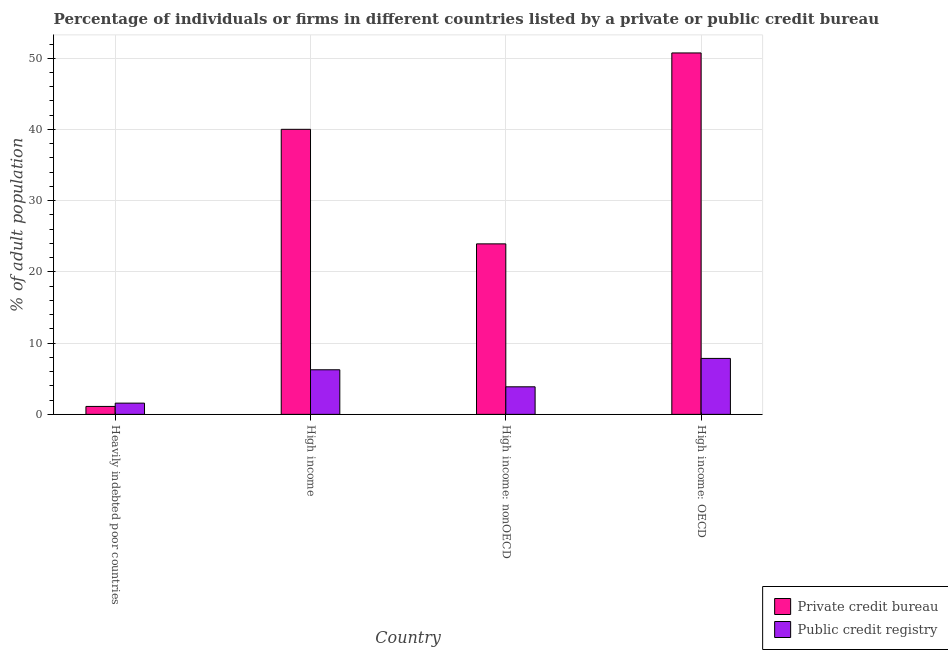How many groups of bars are there?
Keep it short and to the point. 4. Are the number of bars per tick equal to the number of legend labels?
Provide a succinct answer. Yes. Are the number of bars on each tick of the X-axis equal?
Offer a terse response. Yes. What is the label of the 1st group of bars from the left?
Offer a terse response. Heavily indebted poor countries. What is the percentage of firms listed by private credit bureau in High income: nonOECD?
Your answer should be very brief. 23.94. Across all countries, what is the maximum percentage of firms listed by private credit bureau?
Your answer should be compact. 50.75. Across all countries, what is the minimum percentage of firms listed by public credit bureau?
Provide a short and direct response. 1.58. In which country was the percentage of firms listed by public credit bureau maximum?
Ensure brevity in your answer.  High income: OECD. In which country was the percentage of firms listed by public credit bureau minimum?
Your response must be concise. Heavily indebted poor countries. What is the total percentage of firms listed by public credit bureau in the graph?
Provide a succinct answer. 19.57. What is the difference between the percentage of firms listed by public credit bureau in Heavily indebted poor countries and that in High income?
Offer a very short reply. -4.68. What is the difference between the percentage of firms listed by public credit bureau in High income: OECD and the percentage of firms listed by private credit bureau in Heavily indebted poor countries?
Give a very brief answer. 6.74. What is the average percentage of firms listed by public credit bureau per country?
Your response must be concise. 4.89. What is the difference between the percentage of firms listed by private credit bureau and percentage of firms listed by public credit bureau in Heavily indebted poor countries?
Provide a succinct answer. -0.46. What is the ratio of the percentage of firms listed by private credit bureau in High income to that in High income: OECD?
Keep it short and to the point. 0.79. What is the difference between the highest and the second highest percentage of firms listed by public credit bureau?
Offer a very short reply. 1.59. What is the difference between the highest and the lowest percentage of firms listed by private credit bureau?
Offer a terse response. 49.63. In how many countries, is the percentage of firms listed by private credit bureau greater than the average percentage of firms listed by private credit bureau taken over all countries?
Provide a succinct answer. 2. Is the sum of the percentage of firms listed by private credit bureau in High income: OECD and High income: nonOECD greater than the maximum percentage of firms listed by public credit bureau across all countries?
Offer a terse response. Yes. What does the 2nd bar from the left in High income represents?
Your answer should be very brief. Public credit registry. What does the 1st bar from the right in Heavily indebted poor countries represents?
Offer a very short reply. Public credit registry. How many bars are there?
Offer a terse response. 8. Are all the bars in the graph horizontal?
Ensure brevity in your answer.  No. Are the values on the major ticks of Y-axis written in scientific E-notation?
Keep it short and to the point. No. Does the graph contain any zero values?
Give a very brief answer. No. What is the title of the graph?
Give a very brief answer. Percentage of individuals or firms in different countries listed by a private or public credit bureau. Does "International Visitors" appear as one of the legend labels in the graph?
Provide a short and direct response. No. What is the label or title of the X-axis?
Keep it short and to the point. Country. What is the label or title of the Y-axis?
Provide a succinct answer. % of adult population. What is the % of adult population in Private credit bureau in Heavily indebted poor countries?
Your answer should be very brief. 1.12. What is the % of adult population in Public credit registry in Heavily indebted poor countries?
Offer a terse response. 1.58. What is the % of adult population of Private credit bureau in High income?
Ensure brevity in your answer.  40.02. What is the % of adult population of Public credit registry in High income?
Your answer should be very brief. 6.26. What is the % of adult population of Private credit bureau in High income: nonOECD?
Make the answer very short. 23.94. What is the % of adult population in Public credit registry in High income: nonOECD?
Provide a short and direct response. 3.87. What is the % of adult population of Private credit bureau in High income: OECD?
Your answer should be very brief. 50.75. What is the % of adult population in Public credit registry in High income: OECD?
Offer a very short reply. 7.86. Across all countries, what is the maximum % of adult population of Private credit bureau?
Your response must be concise. 50.75. Across all countries, what is the maximum % of adult population in Public credit registry?
Provide a succinct answer. 7.86. Across all countries, what is the minimum % of adult population of Private credit bureau?
Offer a very short reply. 1.12. Across all countries, what is the minimum % of adult population in Public credit registry?
Your answer should be very brief. 1.58. What is the total % of adult population of Private credit bureau in the graph?
Make the answer very short. 115.83. What is the total % of adult population in Public credit registry in the graph?
Offer a terse response. 19.57. What is the difference between the % of adult population of Private credit bureau in Heavily indebted poor countries and that in High income?
Your response must be concise. -38.91. What is the difference between the % of adult population in Public credit registry in Heavily indebted poor countries and that in High income?
Give a very brief answer. -4.68. What is the difference between the % of adult population in Private credit bureau in Heavily indebted poor countries and that in High income: nonOECD?
Provide a short and direct response. -22.82. What is the difference between the % of adult population of Public credit registry in Heavily indebted poor countries and that in High income: nonOECD?
Ensure brevity in your answer.  -2.29. What is the difference between the % of adult population in Private credit bureau in Heavily indebted poor countries and that in High income: OECD?
Your answer should be very brief. -49.63. What is the difference between the % of adult population of Public credit registry in Heavily indebted poor countries and that in High income: OECD?
Ensure brevity in your answer.  -6.28. What is the difference between the % of adult population of Private credit bureau in High income and that in High income: nonOECD?
Ensure brevity in your answer.  16.08. What is the difference between the % of adult population of Public credit registry in High income and that in High income: nonOECD?
Offer a very short reply. 2.39. What is the difference between the % of adult population in Private credit bureau in High income and that in High income: OECD?
Ensure brevity in your answer.  -10.72. What is the difference between the % of adult population in Public credit registry in High income and that in High income: OECD?
Provide a succinct answer. -1.59. What is the difference between the % of adult population of Private credit bureau in High income: nonOECD and that in High income: OECD?
Your response must be concise. -26.81. What is the difference between the % of adult population in Public credit registry in High income: nonOECD and that in High income: OECD?
Your answer should be very brief. -3.99. What is the difference between the % of adult population of Private credit bureau in Heavily indebted poor countries and the % of adult population of Public credit registry in High income?
Keep it short and to the point. -5.15. What is the difference between the % of adult population of Private credit bureau in Heavily indebted poor countries and the % of adult population of Public credit registry in High income: nonOECD?
Your answer should be compact. -2.75. What is the difference between the % of adult population of Private credit bureau in Heavily indebted poor countries and the % of adult population of Public credit registry in High income: OECD?
Your answer should be compact. -6.74. What is the difference between the % of adult population in Private credit bureau in High income and the % of adult population in Public credit registry in High income: nonOECD?
Give a very brief answer. 36.15. What is the difference between the % of adult population in Private credit bureau in High income and the % of adult population in Public credit registry in High income: OECD?
Provide a succinct answer. 32.17. What is the difference between the % of adult population in Private credit bureau in High income: nonOECD and the % of adult population in Public credit registry in High income: OECD?
Provide a short and direct response. 16.08. What is the average % of adult population in Private credit bureau per country?
Your answer should be compact. 28.96. What is the average % of adult population of Public credit registry per country?
Make the answer very short. 4.89. What is the difference between the % of adult population in Private credit bureau and % of adult population in Public credit registry in Heavily indebted poor countries?
Make the answer very short. -0.46. What is the difference between the % of adult population of Private credit bureau and % of adult population of Public credit registry in High income?
Offer a very short reply. 33.76. What is the difference between the % of adult population in Private credit bureau and % of adult population in Public credit registry in High income: nonOECD?
Offer a terse response. 20.07. What is the difference between the % of adult population of Private credit bureau and % of adult population of Public credit registry in High income: OECD?
Provide a short and direct response. 42.89. What is the ratio of the % of adult population in Private credit bureau in Heavily indebted poor countries to that in High income?
Offer a very short reply. 0.03. What is the ratio of the % of adult population of Public credit registry in Heavily indebted poor countries to that in High income?
Your response must be concise. 0.25. What is the ratio of the % of adult population in Private credit bureau in Heavily indebted poor countries to that in High income: nonOECD?
Provide a succinct answer. 0.05. What is the ratio of the % of adult population of Public credit registry in Heavily indebted poor countries to that in High income: nonOECD?
Your answer should be compact. 0.41. What is the ratio of the % of adult population of Private credit bureau in Heavily indebted poor countries to that in High income: OECD?
Your answer should be very brief. 0.02. What is the ratio of the % of adult population of Public credit registry in Heavily indebted poor countries to that in High income: OECD?
Your answer should be compact. 0.2. What is the ratio of the % of adult population in Private credit bureau in High income to that in High income: nonOECD?
Give a very brief answer. 1.67. What is the ratio of the % of adult population of Public credit registry in High income to that in High income: nonOECD?
Offer a very short reply. 1.62. What is the ratio of the % of adult population of Private credit bureau in High income to that in High income: OECD?
Your answer should be very brief. 0.79. What is the ratio of the % of adult population of Public credit registry in High income to that in High income: OECD?
Your answer should be compact. 0.8. What is the ratio of the % of adult population of Private credit bureau in High income: nonOECD to that in High income: OECD?
Keep it short and to the point. 0.47. What is the ratio of the % of adult population in Public credit registry in High income: nonOECD to that in High income: OECD?
Provide a succinct answer. 0.49. What is the difference between the highest and the second highest % of adult population in Private credit bureau?
Your response must be concise. 10.72. What is the difference between the highest and the second highest % of adult population of Public credit registry?
Your answer should be compact. 1.59. What is the difference between the highest and the lowest % of adult population of Private credit bureau?
Your answer should be compact. 49.63. What is the difference between the highest and the lowest % of adult population in Public credit registry?
Your response must be concise. 6.28. 